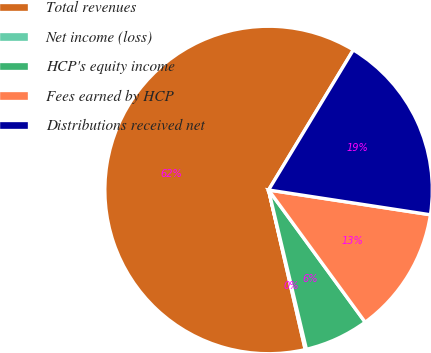Convert chart to OTSL. <chart><loc_0><loc_0><loc_500><loc_500><pie_chart><fcel>Total revenues<fcel>Net income (loss)<fcel>HCP's equity income<fcel>Fees earned by HCP<fcel>Distributions received net<nl><fcel>62.25%<fcel>0.12%<fcel>6.33%<fcel>12.54%<fcel>18.76%<nl></chart> 